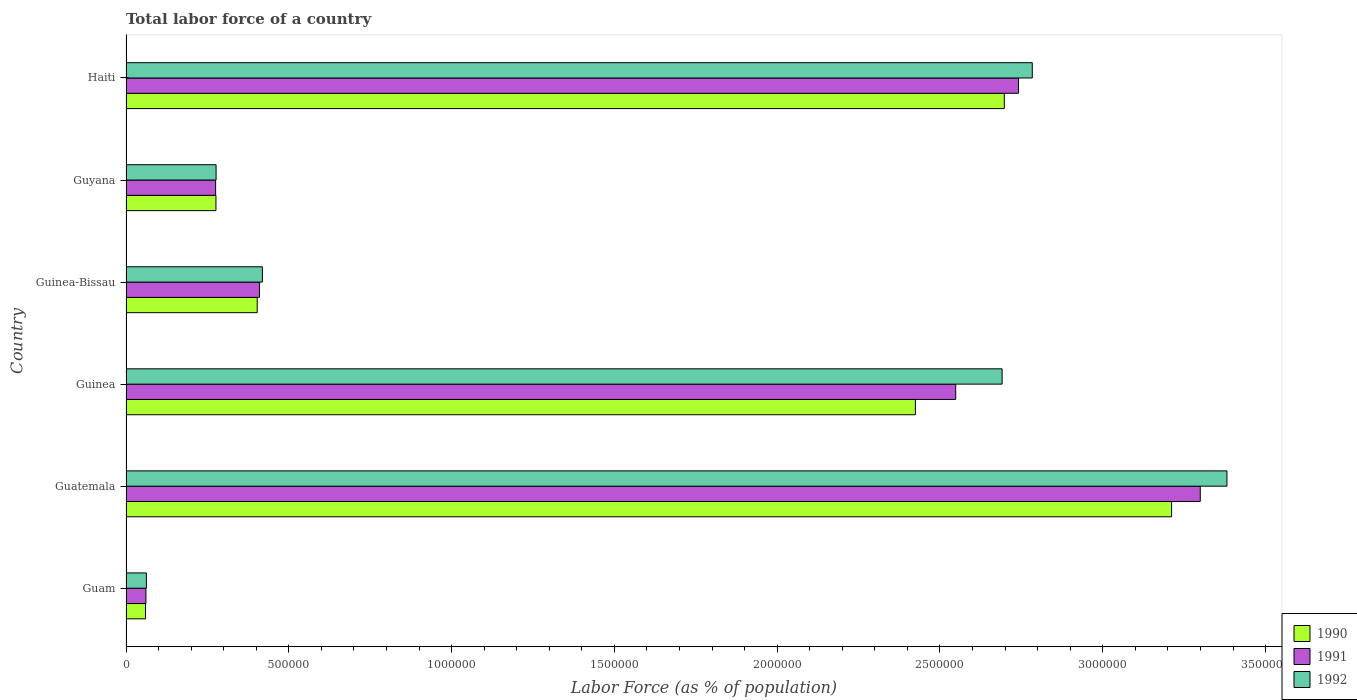How many different coloured bars are there?
Keep it short and to the point. 3. Are the number of bars on each tick of the Y-axis equal?
Your answer should be compact. Yes. How many bars are there on the 5th tick from the top?
Your answer should be compact. 3. What is the label of the 3rd group of bars from the top?
Your answer should be compact. Guinea-Bissau. In how many cases, is the number of bars for a given country not equal to the number of legend labels?
Your answer should be very brief. 0. What is the percentage of labor force in 1990 in Guyana?
Ensure brevity in your answer.  2.76e+05. Across all countries, what is the maximum percentage of labor force in 1991?
Your answer should be very brief. 3.30e+06. Across all countries, what is the minimum percentage of labor force in 1990?
Give a very brief answer. 5.98e+04. In which country was the percentage of labor force in 1990 maximum?
Keep it short and to the point. Guatemala. In which country was the percentage of labor force in 1990 minimum?
Give a very brief answer. Guam. What is the total percentage of labor force in 1992 in the graph?
Your answer should be compact. 9.61e+06. What is the difference between the percentage of labor force in 1991 in Guam and that in Guyana?
Offer a very short reply. -2.14e+05. What is the difference between the percentage of labor force in 1992 in Haiti and the percentage of labor force in 1991 in Guinea?
Make the answer very short. 2.35e+05. What is the average percentage of labor force in 1991 per country?
Offer a very short reply. 1.56e+06. What is the difference between the percentage of labor force in 1991 and percentage of labor force in 1992 in Haiti?
Give a very brief answer. -4.24e+04. In how many countries, is the percentage of labor force in 1991 greater than 1400000 %?
Offer a very short reply. 3. What is the ratio of the percentage of labor force in 1990 in Guinea to that in Guinea-Bissau?
Make the answer very short. 6.02. What is the difference between the highest and the second highest percentage of labor force in 1990?
Your answer should be compact. 5.14e+05. What is the difference between the highest and the lowest percentage of labor force in 1990?
Provide a short and direct response. 3.15e+06. In how many countries, is the percentage of labor force in 1991 greater than the average percentage of labor force in 1991 taken over all countries?
Give a very brief answer. 3. Is the sum of the percentage of labor force in 1992 in Guatemala and Guinea-Bissau greater than the maximum percentage of labor force in 1990 across all countries?
Offer a very short reply. Yes. What does the 2nd bar from the top in Guatemala represents?
Offer a very short reply. 1991. Is it the case that in every country, the sum of the percentage of labor force in 1990 and percentage of labor force in 1991 is greater than the percentage of labor force in 1992?
Offer a terse response. Yes. Are all the bars in the graph horizontal?
Keep it short and to the point. Yes. How many countries are there in the graph?
Offer a terse response. 6. What is the difference between two consecutive major ticks on the X-axis?
Provide a succinct answer. 5.00e+05. Are the values on the major ticks of X-axis written in scientific E-notation?
Offer a very short reply. No. Does the graph contain grids?
Provide a succinct answer. No. Where does the legend appear in the graph?
Give a very brief answer. Bottom right. How many legend labels are there?
Provide a succinct answer. 3. How are the legend labels stacked?
Ensure brevity in your answer.  Vertical. What is the title of the graph?
Provide a short and direct response. Total labor force of a country. What is the label or title of the X-axis?
Your response must be concise. Labor Force (as % of population). What is the Labor Force (as % of population) of 1990 in Guam?
Your answer should be compact. 5.98e+04. What is the Labor Force (as % of population) of 1991 in Guam?
Offer a terse response. 6.12e+04. What is the Labor Force (as % of population) in 1992 in Guam?
Provide a succinct answer. 6.25e+04. What is the Labor Force (as % of population) in 1990 in Guatemala?
Offer a terse response. 3.21e+06. What is the Labor Force (as % of population) of 1991 in Guatemala?
Provide a succinct answer. 3.30e+06. What is the Labor Force (as % of population) of 1992 in Guatemala?
Keep it short and to the point. 3.38e+06. What is the Labor Force (as % of population) in 1990 in Guinea?
Ensure brevity in your answer.  2.42e+06. What is the Labor Force (as % of population) in 1991 in Guinea?
Provide a succinct answer. 2.55e+06. What is the Labor Force (as % of population) in 1992 in Guinea?
Give a very brief answer. 2.69e+06. What is the Labor Force (as % of population) in 1990 in Guinea-Bissau?
Ensure brevity in your answer.  4.03e+05. What is the Labor Force (as % of population) in 1991 in Guinea-Bissau?
Offer a very short reply. 4.10e+05. What is the Labor Force (as % of population) of 1992 in Guinea-Bissau?
Make the answer very short. 4.19e+05. What is the Labor Force (as % of population) in 1990 in Guyana?
Provide a succinct answer. 2.76e+05. What is the Labor Force (as % of population) in 1991 in Guyana?
Ensure brevity in your answer.  2.75e+05. What is the Labor Force (as % of population) of 1992 in Guyana?
Offer a terse response. 2.77e+05. What is the Labor Force (as % of population) in 1990 in Haiti?
Offer a very short reply. 2.70e+06. What is the Labor Force (as % of population) in 1991 in Haiti?
Give a very brief answer. 2.74e+06. What is the Labor Force (as % of population) of 1992 in Haiti?
Your response must be concise. 2.78e+06. Across all countries, what is the maximum Labor Force (as % of population) in 1990?
Provide a short and direct response. 3.21e+06. Across all countries, what is the maximum Labor Force (as % of population) of 1991?
Ensure brevity in your answer.  3.30e+06. Across all countries, what is the maximum Labor Force (as % of population) in 1992?
Keep it short and to the point. 3.38e+06. Across all countries, what is the minimum Labor Force (as % of population) of 1990?
Offer a very short reply. 5.98e+04. Across all countries, what is the minimum Labor Force (as % of population) of 1991?
Offer a terse response. 6.12e+04. Across all countries, what is the minimum Labor Force (as % of population) in 1992?
Make the answer very short. 6.25e+04. What is the total Labor Force (as % of population) in 1990 in the graph?
Give a very brief answer. 9.07e+06. What is the total Labor Force (as % of population) of 1991 in the graph?
Offer a very short reply. 9.34e+06. What is the total Labor Force (as % of population) of 1992 in the graph?
Provide a short and direct response. 9.61e+06. What is the difference between the Labor Force (as % of population) of 1990 in Guam and that in Guatemala?
Offer a terse response. -3.15e+06. What is the difference between the Labor Force (as % of population) in 1991 in Guam and that in Guatemala?
Provide a short and direct response. -3.24e+06. What is the difference between the Labor Force (as % of population) in 1992 in Guam and that in Guatemala?
Offer a very short reply. -3.32e+06. What is the difference between the Labor Force (as % of population) in 1990 in Guam and that in Guinea?
Offer a very short reply. -2.36e+06. What is the difference between the Labor Force (as % of population) in 1991 in Guam and that in Guinea?
Your answer should be very brief. -2.49e+06. What is the difference between the Labor Force (as % of population) of 1992 in Guam and that in Guinea?
Provide a succinct answer. -2.63e+06. What is the difference between the Labor Force (as % of population) of 1990 in Guam and that in Guinea-Bissau?
Your answer should be very brief. -3.43e+05. What is the difference between the Labor Force (as % of population) in 1991 in Guam and that in Guinea-Bissau?
Ensure brevity in your answer.  -3.49e+05. What is the difference between the Labor Force (as % of population) in 1992 in Guam and that in Guinea-Bissau?
Give a very brief answer. -3.56e+05. What is the difference between the Labor Force (as % of population) in 1990 in Guam and that in Guyana?
Provide a succinct answer. -2.16e+05. What is the difference between the Labor Force (as % of population) in 1991 in Guam and that in Guyana?
Keep it short and to the point. -2.14e+05. What is the difference between the Labor Force (as % of population) in 1992 in Guam and that in Guyana?
Keep it short and to the point. -2.14e+05. What is the difference between the Labor Force (as % of population) in 1990 in Guam and that in Haiti?
Your answer should be compact. -2.64e+06. What is the difference between the Labor Force (as % of population) in 1991 in Guam and that in Haiti?
Give a very brief answer. -2.68e+06. What is the difference between the Labor Force (as % of population) of 1992 in Guam and that in Haiti?
Keep it short and to the point. -2.72e+06. What is the difference between the Labor Force (as % of population) of 1990 in Guatemala and that in Guinea?
Ensure brevity in your answer.  7.87e+05. What is the difference between the Labor Force (as % of population) of 1991 in Guatemala and that in Guinea?
Keep it short and to the point. 7.51e+05. What is the difference between the Labor Force (as % of population) of 1992 in Guatemala and that in Guinea?
Keep it short and to the point. 6.91e+05. What is the difference between the Labor Force (as % of population) of 1990 in Guatemala and that in Guinea-Bissau?
Provide a succinct answer. 2.81e+06. What is the difference between the Labor Force (as % of population) in 1991 in Guatemala and that in Guinea-Bissau?
Offer a terse response. 2.89e+06. What is the difference between the Labor Force (as % of population) of 1992 in Guatemala and that in Guinea-Bissau?
Give a very brief answer. 2.96e+06. What is the difference between the Labor Force (as % of population) of 1990 in Guatemala and that in Guyana?
Keep it short and to the point. 2.94e+06. What is the difference between the Labor Force (as % of population) in 1991 in Guatemala and that in Guyana?
Keep it short and to the point. 3.02e+06. What is the difference between the Labor Force (as % of population) of 1992 in Guatemala and that in Guyana?
Offer a very short reply. 3.10e+06. What is the difference between the Labor Force (as % of population) in 1990 in Guatemala and that in Haiti?
Your response must be concise. 5.14e+05. What is the difference between the Labor Force (as % of population) in 1991 in Guatemala and that in Haiti?
Offer a terse response. 5.58e+05. What is the difference between the Labor Force (as % of population) in 1992 in Guatemala and that in Haiti?
Your answer should be compact. 5.98e+05. What is the difference between the Labor Force (as % of population) of 1990 in Guinea and that in Guinea-Bissau?
Keep it short and to the point. 2.02e+06. What is the difference between the Labor Force (as % of population) in 1991 in Guinea and that in Guinea-Bissau?
Keep it short and to the point. 2.14e+06. What is the difference between the Labor Force (as % of population) in 1992 in Guinea and that in Guinea-Bissau?
Your response must be concise. 2.27e+06. What is the difference between the Labor Force (as % of population) in 1990 in Guinea and that in Guyana?
Your answer should be compact. 2.15e+06. What is the difference between the Labor Force (as % of population) of 1991 in Guinea and that in Guyana?
Provide a short and direct response. 2.27e+06. What is the difference between the Labor Force (as % of population) in 1992 in Guinea and that in Guyana?
Your response must be concise. 2.41e+06. What is the difference between the Labor Force (as % of population) of 1990 in Guinea and that in Haiti?
Give a very brief answer. -2.73e+05. What is the difference between the Labor Force (as % of population) of 1991 in Guinea and that in Haiti?
Offer a terse response. -1.93e+05. What is the difference between the Labor Force (as % of population) in 1992 in Guinea and that in Haiti?
Give a very brief answer. -9.27e+04. What is the difference between the Labor Force (as % of population) in 1990 in Guinea-Bissau and that in Guyana?
Provide a succinct answer. 1.27e+05. What is the difference between the Labor Force (as % of population) of 1991 in Guinea-Bissau and that in Guyana?
Keep it short and to the point. 1.35e+05. What is the difference between the Labor Force (as % of population) of 1992 in Guinea-Bissau and that in Guyana?
Your response must be concise. 1.42e+05. What is the difference between the Labor Force (as % of population) of 1990 in Guinea-Bissau and that in Haiti?
Your response must be concise. -2.29e+06. What is the difference between the Labor Force (as % of population) in 1991 in Guinea-Bissau and that in Haiti?
Provide a succinct answer. -2.33e+06. What is the difference between the Labor Force (as % of population) in 1992 in Guinea-Bissau and that in Haiti?
Provide a succinct answer. -2.36e+06. What is the difference between the Labor Force (as % of population) in 1990 in Guyana and that in Haiti?
Your response must be concise. -2.42e+06. What is the difference between the Labor Force (as % of population) of 1991 in Guyana and that in Haiti?
Give a very brief answer. -2.47e+06. What is the difference between the Labor Force (as % of population) of 1992 in Guyana and that in Haiti?
Offer a very short reply. -2.51e+06. What is the difference between the Labor Force (as % of population) of 1990 in Guam and the Labor Force (as % of population) of 1991 in Guatemala?
Provide a succinct answer. -3.24e+06. What is the difference between the Labor Force (as % of population) in 1990 in Guam and the Labor Force (as % of population) in 1992 in Guatemala?
Provide a succinct answer. -3.32e+06. What is the difference between the Labor Force (as % of population) of 1991 in Guam and the Labor Force (as % of population) of 1992 in Guatemala?
Ensure brevity in your answer.  -3.32e+06. What is the difference between the Labor Force (as % of population) of 1990 in Guam and the Labor Force (as % of population) of 1991 in Guinea?
Give a very brief answer. -2.49e+06. What is the difference between the Labor Force (as % of population) in 1990 in Guam and the Labor Force (as % of population) in 1992 in Guinea?
Make the answer very short. -2.63e+06. What is the difference between the Labor Force (as % of population) of 1991 in Guam and the Labor Force (as % of population) of 1992 in Guinea?
Offer a terse response. -2.63e+06. What is the difference between the Labor Force (as % of population) of 1990 in Guam and the Labor Force (as % of population) of 1991 in Guinea-Bissau?
Ensure brevity in your answer.  -3.50e+05. What is the difference between the Labor Force (as % of population) in 1990 in Guam and the Labor Force (as % of population) in 1992 in Guinea-Bissau?
Offer a terse response. -3.59e+05. What is the difference between the Labor Force (as % of population) in 1991 in Guam and the Labor Force (as % of population) in 1992 in Guinea-Bissau?
Give a very brief answer. -3.58e+05. What is the difference between the Labor Force (as % of population) in 1990 in Guam and the Labor Force (as % of population) in 1991 in Guyana?
Your answer should be compact. -2.15e+05. What is the difference between the Labor Force (as % of population) of 1990 in Guam and the Labor Force (as % of population) of 1992 in Guyana?
Offer a very short reply. -2.17e+05. What is the difference between the Labor Force (as % of population) of 1991 in Guam and the Labor Force (as % of population) of 1992 in Guyana?
Ensure brevity in your answer.  -2.15e+05. What is the difference between the Labor Force (as % of population) in 1990 in Guam and the Labor Force (as % of population) in 1991 in Haiti?
Keep it short and to the point. -2.68e+06. What is the difference between the Labor Force (as % of population) in 1990 in Guam and the Labor Force (as % of population) in 1992 in Haiti?
Offer a very short reply. -2.72e+06. What is the difference between the Labor Force (as % of population) of 1991 in Guam and the Labor Force (as % of population) of 1992 in Haiti?
Offer a terse response. -2.72e+06. What is the difference between the Labor Force (as % of population) in 1990 in Guatemala and the Labor Force (as % of population) in 1991 in Guinea?
Ensure brevity in your answer.  6.63e+05. What is the difference between the Labor Force (as % of population) in 1990 in Guatemala and the Labor Force (as % of population) in 1992 in Guinea?
Ensure brevity in your answer.  5.21e+05. What is the difference between the Labor Force (as % of population) in 1991 in Guatemala and the Labor Force (as % of population) in 1992 in Guinea?
Provide a short and direct response. 6.09e+05. What is the difference between the Labor Force (as % of population) in 1990 in Guatemala and the Labor Force (as % of population) in 1991 in Guinea-Bissau?
Provide a succinct answer. 2.80e+06. What is the difference between the Labor Force (as % of population) of 1990 in Guatemala and the Labor Force (as % of population) of 1992 in Guinea-Bissau?
Offer a terse response. 2.79e+06. What is the difference between the Labor Force (as % of population) of 1991 in Guatemala and the Labor Force (as % of population) of 1992 in Guinea-Bissau?
Make the answer very short. 2.88e+06. What is the difference between the Labor Force (as % of population) of 1990 in Guatemala and the Labor Force (as % of population) of 1991 in Guyana?
Make the answer very short. 2.94e+06. What is the difference between the Labor Force (as % of population) in 1990 in Guatemala and the Labor Force (as % of population) in 1992 in Guyana?
Provide a succinct answer. 2.93e+06. What is the difference between the Labor Force (as % of population) in 1991 in Guatemala and the Labor Force (as % of population) in 1992 in Guyana?
Your response must be concise. 3.02e+06. What is the difference between the Labor Force (as % of population) in 1990 in Guatemala and the Labor Force (as % of population) in 1991 in Haiti?
Your response must be concise. 4.70e+05. What is the difference between the Labor Force (as % of population) in 1990 in Guatemala and the Labor Force (as % of population) in 1992 in Haiti?
Offer a terse response. 4.28e+05. What is the difference between the Labor Force (as % of population) in 1991 in Guatemala and the Labor Force (as % of population) in 1992 in Haiti?
Your answer should be very brief. 5.16e+05. What is the difference between the Labor Force (as % of population) in 1990 in Guinea and the Labor Force (as % of population) in 1991 in Guinea-Bissau?
Give a very brief answer. 2.01e+06. What is the difference between the Labor Force (as % of population) of 1990 in Guinea and the Labor Force (as % of population) of 1992 in Guinea-Bissau?
Provide a succinct answer. 2.01e+06. What is the difference between the Labor Force (as % of population) in 1991 in Guinea and the Labor Force (as % of population) in 1992 in Guinea-Bissau?
Provide a succinct answer. 2.13e+06. What is the difference between the Labor Force (as % of population) in 1990 in Guinea and the Labor Force (as % of population) in 1991 in Guyana?
Ensure brevity in your answer.  2.15e+06. What is the difference between the Labor Force (as % of population) in 1990 in Guinea and the Labor Force (as % of population) in 1992 in Guyana?
Offer a very short reply. 2.15e+06. What is the difference between the Labor Force (as % of population) of 1991 in Guinea and the Labor Force (as % of population) of 1992 in Guyana?
Ensure brevity in your answer.  2.27e+06. What is the difference between the Labor Force (as % of population) of 1990 in Guinea and the Labor Force (as % of population) of 1991 in Haiti?
Your response must be concise. -3.17e+05. What is the difference between the Labor Force (as % of population) in 1990 in Guinea and the Labor Force (as % of population) in 1992 in Haiti?
Ensure brevity in your answer.  -3.59e+05. What is the difference between the Labor Force (as % of population) in 1991 in Guinea and the Labor Force (as % of population) in 1992 in Haiti?
Offer a very short reply. -2.35e+05. What is the difference between the Labor Force (as % of population) of 1990 in Guinea-Bissau and the Labor Force (as % of population) of 1991 in Guyana?
Provide a succinct answer. 1.28e+05. What is the difference between the Labor Force (as % of population) of 1990 in Guinea-Bissau and the Labor Force (as % of population) of 1992 in Guyana?
Ensure brevity in your answer.  1.26e+05. What is the difference between the Labor Force (as % of population) of 1991 in Guinea-Bissau and the Labor Force (as % of population) of 1992 in Guyana?
Give a very brief answer. 1.33e+05. What is the difference between the Labor Force (as % of population) of 1990 in Guinea-Bissau and the Labor Force (as % of population) of 1991 in Haiti?
Offer a very short reply. -2.34e+06. What is the difference between the Labor Force (as % of population) of 1990 in Guinea-Bissau and the Labor Force (as % of population) of 1992 in Haiti?
Give a very brief answer. -2.38e+06. What is the difference between the Labor Force (as % of population) of 1991 in Guinea-Bissau and the Labor Force (as % of population) of 1992 in Haiti?
Give a very brief answer. -2.37e+06. What is the difference between the Labor Force (as % of population) in 1990 in Guyana and the Labor Force (as % of population) in 1991 in Haiti?
Provide a succinct answer. -2.46e+06. What is the difference between the Labor Force (as % of population) in 1990 in Guyana and the Labor Force (as % of population) in 1992 in Haiti?
Give a very brief answer. -2.51e+06. What is the difference between the Labor Force (as % of population) in 1991 in Guyana and the Labor Force (as % of population) in 1992 in Haiti?
Offer a very short reply. -2.51e+06. What is the average Labor Force (as % of population) in 1990 per country?
Keep it short and to the point. 1.51e+06. What is the average Labor Force (as % of population) of 1991 per country?
Offer a terse response. 1.56e+06. What is the average Labor Force (as % of population) of 1992 per country?
Your answer should be very brief. 1.60e+06. What is the difference between the Labor Force (as % of population) in 1990 and Labor Force (as % of population) in 1991 in Guam?
Ensure brevity in your answer.  -1353. What is the difference between the Labor Force (as % of population) of 1990 and Labor Force (as % of population) of 1992 in Guam?
Give a very brief answer. -2683. What is the difference between the Labor Force (as % of population) of 1991 and Labor Force (as % of population) of 1992 in Guam?
Make the answer very short. -1330. What is the difference between the Labor Force (as % of population) of 1990 and Labor Force (as % of population) of 1991 in Guatemala?
Keep it short and to the point. -8.81e+04. What is the difference between the Labor Force (as % of population) in 1990 and Labor Force (as % of population) in 1992 in Guatemala?
Offer a terse response. -1.70e+05. What is the difference between the Labor Force (as % of population) of 1991 and Labor Force (as % of population) of 1992 in Guatemala?
Your answer should be compact. -8.19e+04. What is the difference between the Labor Force (as % of population) of 1990 and Labor Force (as % of population) of 1991 in Guinea?
Your answer should be very brief. -1.24e+05. What is the difference between the Labor Force (as % of population) in 1990 and Labor Force (as % of population) in 1992 in Guinea?
Ensure brevity in your answer.  -2.66e+05. What is the difference between the Labor Force (as % of population) of 1991 and Labor Force (as % of population) of 1992 in Guinea?
Provide a short and direct response. -1.43e+05. What is the difference between the Labor Force (as % of population) in 1990 and Labor Force (as % of population) in 1991 in Guinea-Bissau?
Keep it short and to the point. -6866. What is the difference between the Labor Force (as % of population) in 1990 and Labor Force (as % of population) in 1992 in Guinea-Bissau?
Your answer should be compact. -1.58e+04. What is the difference between the Labor Force (as % of population) in 1991 and Labor Force (as % of population) in 1992 in Guinea-Bissau?
Ensure brevity in your answer.  -8973. What is the difference between the Labor Force (as % of population) of 1990 and Labor Force (as % of population) of 1991 in Guyana?
Offer a terse response. 979. What is the difference between the Labor Force (as % of population) in 1990 and Labor Force (as % of population) in 1992 in Guyana?
Your response must be concise. -413. What is the difference between the Labor Force (as % of population) of 1991 and Labor Force (as % of population) of 1992 in Guyana?
Provide a short and direct response. -1392. What is the difference between the Labor Force (as % of population) of 1990 and Labor Force (as % of population) of 1991 in Haiti?
Offer a terse response. -4.36e+04. What is the difference between the Labor Force (as % of population) in 1990 and Labor Force (as % of population) in 1992 in Haiti?
Keep it short and to the point. -8.59e+04. What is the difference between the Labor Force (as % of population) of 1991 and Labor Force (as % of population) of 1992 in Haiti?
Offer a very short reply. -4.24e+04. What is the ratio of the Labor Force (as % of population) in 1990 in Guam to that in Guatemala?
Ensure brevity in your answer.  0.02. What is the ratio of the Labor Force (as % of population) in 1991 in Guam to that in Guatemala?
Your answer should be very brief. 0.02. What is the ratio of the Labor Force (as % of population) of 1992 in Guam to that in Guatemala?
Offer a terse response. 0.02. What is the ratio of the Labor Force (as % of population) in 1990 in Guam to that in Guinea?
Your answer should be compact. 0.02. What is the ratio of the Labor Force (as % of population) of 1991 in Guam to that in Guinea?
Your answer should be very brief. 0.02. What is the ratio of the Labor Force (as % of population) in 1992 in Guam to that in Guinea?
Offer a terse response. 0.02. What is the ratio of the Labor Force (as % of population) of 1990 in Guam to that in Guinea-Bissau?
Provide a short and direct response. 0.15. What is the ratio of the Labor Force (as % of population) in 1991 in Guam to that in Guinea-Bissau?
Make the answer very short. 0.15. What is the ratio of the Labor Force (as % of population) of 1992 in Guam to that in Guinea-Bissau?
Your response must be concise. 0.15. What is the ratio of the Labor Force (as % of population) of 1990 in Guam to that in Guyana?
Your response must be concise. 0.22. What is the ratio of the Labor Force (as % of population) in 1991 in Guam to that in Guyana?
Give a very brief answer. 0.22. What is the ratio of the Labor Force (as % of population) in 1992 in Guam to that in Guyana?
Provide a short and direct response. 0.23. What is the ratio of the Labor Force (as % of population) in 1990 in Guam to that in Haiti?
Your answer should be compact. 0.02. What is the ratio of the Labor Force (as % of population) of 1991 in Guam to that in Haiti?
Ensure brevity in your answer.  0.02. What is the ratio of the Labor Force (as % of population) of 1992 in Guam to that in Haiti?
Provide a short and direct response. 0.02. What is the ratio of the Labor Force (as % of population) in 1990 in Guatemala to that in Guinea?
Provide a short and direct response. 1.32. What is the ratio of the Labor Force (as % of population) in 1991 in Guatemala to that in Guinea?
Your answer should be very brief. 1.29. What is the ratio of the Labor Force (as % of population) in 1992 in Guatemala to that in Guinea?
Provide a short and direct response. 1.26. What is the ratio of the Labor Force (as % of population) of 1990 in Guatemala to that in Guinea-Bissau?
Your answer should be very brief. 7.97. What is the ratio of the Labor Force (as % of population) in 1991 in Guatemala to that in Guinea-Bissau?
Offer a very short reply. 8.05. What is the ratio of the Labor Force (as % of population) of 1992 in Guatemala to that in Guinea-Bissau?
Offer a terse response. 8.07. What is the ratio of the Labor Force (as % of population) of 1990 in Guatemala to that in Guyana?
Keep it short and to the point. 11.63. What is the ratio of the Labor Force (as % of population) in 1991 in Guatemala to that in Guyana?
Provide a succinct answer. 11.99. What is the ratio of the Labor Force (as % of population) of 1992 in Guatemala to that in Guyana?
Make the answer very short. 12.22. What is the ratio of the Labor Force (as % of population) of 1990 in Guatemala to that in Haiti?
Your answer should be very brief. 1.19. What is the ratio of the Labor Force (as % of population) in 1991 in Guatemala to that in Haiti?
Your answer should be compact. 1.2. What is the ratio of the Labor Force (as % of population) in 1992 in Guatemala to that in Haiti?
Provide a succinct answer. 1.21. What is the ratio of the Labor Force (as % of population) in 1990 in Guinea to that in Guinea-Bissau?
Provide a short and direct response. 6.02. What is the ratio of the Labor Force (as % of population) of 1991 in Guinea to that in Guinea-Bissau?
Keep it short and to the point. 6.22. What is the ratio of the Labor Force (as % of population) in 1992 in Guinea to that in Guinea-Bissau?
Provide a succinct answer. 6.42. What is the ratio of the Labor Force (as % of population) in 1990 in Guinea to that in Guyana?
Your answer should be very brief. 8.78. What is the ratio of the Labor Force (as % of population) in 1991 in Guinea to that in Guyana?
Offer a terse response. 9.26. What is the ratio of the Labor Force (as % of population) of 1992 in Guinea to that in Guyana?
Offer a very short reply. 9.73. What is the ratio of the Labor Force (as % of population) of 1990 in Guinea to that in Haiti?
Keep it short and to the point. 0.9. What is the ratio of the Labor Force (as % of population) in 1991 in Guinea to that in Haiti?
Provide a succinct answer. 0.93. What is the ratio of the Labor Force (as % of population) in 1992 in Guinea to that in Haiti?
Your response must be concise. 0.97. What is the ratio of the Labor Force (as % of population) in 1990 in Guinea-Bissau to that in Guyana?
Provide a succinct answer. 1.46. What is the ratio of the Labor Force (as % of population) of 1991 in Guinea-Bissau to that in Guyana?
Give a very brief answer. 1.49. What is the ratio of the Labor Force (as % of population) of 1992 in Guinea-Bissau to that in Guyana?
Ensure brevity in your answer.  1.51. What is the ratio of the Labor Force (as % of population) of 1990 in Guinea-Bissau to that in Haiti?
Provide a short and direct response. 0.15. What is the ratio of the Labor Force (as % of population) of 1991 in Guinea-Bissau to that in Haiti?
Offer a very short reply. 0.15. What is the ratio of the Labor Force (as % of population) of 1992 in Guinea-Bissau to that in Haiti?
Offer a terse response. 0.15. What is the ratio of the Labor Force (as % of population) in 1990 in Guyana to that in Haiti?
Provide a succinct answer. 0.1. What is the ratio of the Labor Force (as % of population) of 1991 in Guyana to that in Haiti?
Provide a succinct answer. 0.1. What is the ratio of the Labor Force (as % of population) of 1992 in Guyana to that in Haiti?
Offer a very short reply. 0.1. What is the difference between the highest and the second highest Labor Force (as % of population) in 1990?
Give a very brief answer. 5.14e+05. What is the difference between the highest and the second highest Labor Force (as % of population) in 1991?
Your answer should be compact. 5.58e+05. What is the difference between the highest and the second highest Labor Force (as % of population) in 1992?
Your response must be concise. 5.98e+05. What is the difference between the highest and the lowest Labor Force (as % of population) in 1990?
Your response must be concise. 3.15e+06. What is the difference between the highest and the lowest Labor Force (as % of population) of 1991?
Ensure brevity in your answer.  3.24e+06. What is the difference between the highest and the lowest Labor Force (as % of population) of 1992?
Your response must be concise. 3.32e+06. 